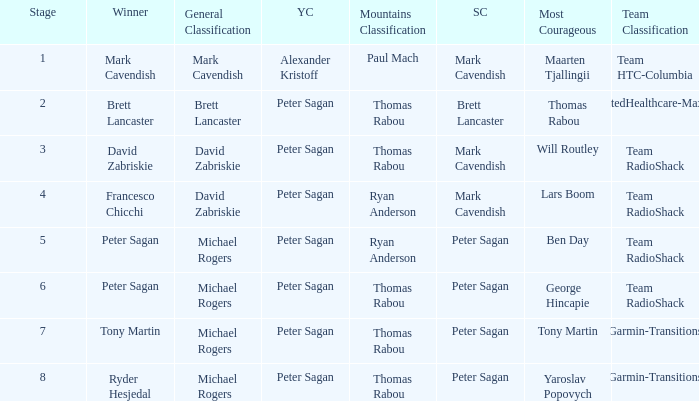When Mark Cavendish wins sprint classification and Maarten Tjallingii wins most courageous, who wins youth classification? Alexander Kristoff. 